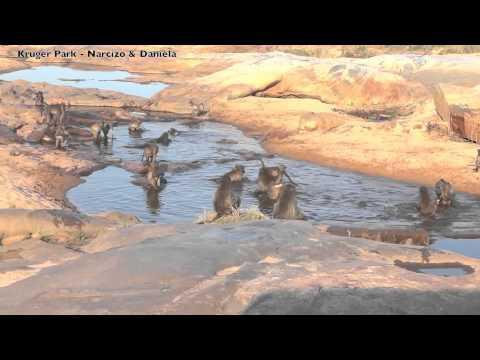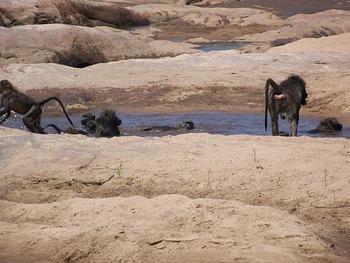The first image is the image on the left, the second image is the image on the right. Evaluate the accuracy of this statement regarding the images: "The right image contains no more than two monkeys.". Is it true? Answer yes or no. No. The first image is the image on the left, the second image is the image on the right. Assess this claim about the two images: "Both images show multiple monkeys in pools of water.". Correct or not? Answer yes or no. Yes. 